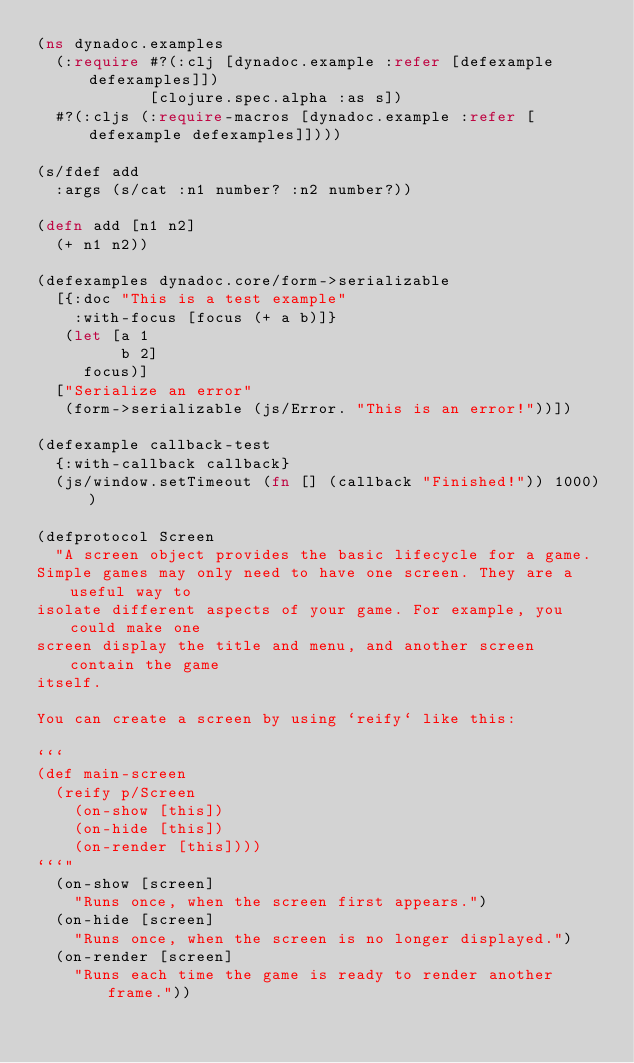<code> <loc_0><loc_0><loc_500><loc_500><_Clojure_>(ns dynadoc.examples
  (:require #?(:clj [dynadoc.example :refer [defexample defexamples]])
            [clojure.spec.alpha :as s])
  #?(:cljs (:require-macros [dynadoc.example :refer [defexample defexamples]])))

(s/fdef add
  :args (s/cat :n1 number? :n2 number?))

(defn add [n1 n2]
  (+ n1 n2))

(defexamples dynadoc.core/form->serializable
  [{:doc "This is a test example"
    :with-focus [focus (+ a b)]}
   (let [a 1
         b 2]
     focus)]
  ["Serialize an error"
   (form->serializable (js/Error. "This is an error!"))])

(defexample callback-test
  {:with-callback callback}
  (js/window.setTimeout (fn [] (callback "Finished!")) 1000))

(defprotocol Screen
  "A screen object provides the basic lifecycle for a game.
Simple games may only need to have one screen. They are a useful way to
isolate different aspects of your game. For example, you could make one
screen display the title and menu, and another screen contain the game
itself. 

You can create a screen by using `reify` like this:

```
(def main-screen
  (reify p/Screen
    (on-show [this])
    (on-hide [this])
    (on-render [this])))
```"
  (on-show [screen]
    "Runs once, when the screen first appears.")
  (on-hide [screen]
    "Runs once, when the screen is no longer displayed.")
  (on-render [screen]
    "Runs each time the game is ready to render another frame."))


</code> 